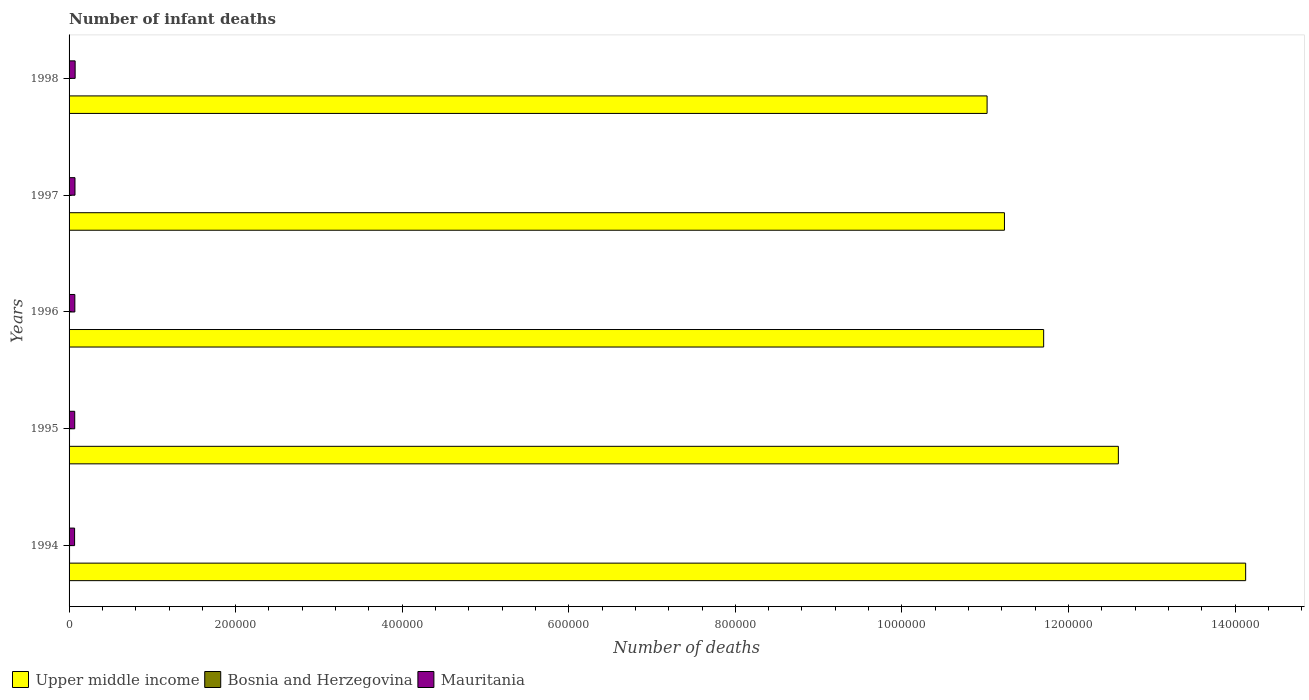How many groups of bars are there?
Ensure brevity in your answer.  5. How many bars are there on the 5th tick from the bottom?
Provide a short and direct response. 3. What is the label of the 2nd group of bars from the top?
Ensure brevity in your answer.  1997. In how many cases, is the number of bars for a given year not equal to the number of legend labels?
Your answer should be very brief. 0. What is the number of infant deaths in Mauritania in 1998?
Ensure brevity in your answer.  7281. Across all years, what is the maximum number of infant deaths in Bosnia and Herzegovina?
Provide a short and direct response. 579. Across all years, what is the minimum number of infant deaths in Upper middle income?
Provide a short and direct response. 1.10e+06. In which year was the number of infant deaths in Mauritania minimum?
Ensure brevity in your answer.  1994. What is the total number of infant deaths in Bosnia and Herzegovina in the graph?
Your answer should be compact. 2478. What is the difference between the number of infant deaths in Bosnia and Herzegovina in 1994 and the number of infant deaths in Mauritania in 1996?
Provide a short and direct response. -6357. What is the average number of infant deaths in Mauritania per year?
Give a very brief answer. 6945.4. In the year 1998, what is the difference between the number of infant deaths in Mauritania and number of infant deaths in Bosnia and Herzegovina?
Your response must be concise. 6840. What is the ratio of the number of infant deaths in Mauritania in 1996 to that in 1998?
Offer a very short reply. 0.95. Is the difference between the number of infant deaths in Mauritania in 1995 and 1997 greater than the difference between the number of infant deaths in Bosnia and Herzegovina in 1995 and 1997?
Give a very brief answer. No. What is the difference between the highest and the second highest number of infant deaths in Mauritania?
Offer a terse response. 178. What is the difference between the highest and the lowest number of infant deaths in Mauritania?
Your answer should be very brief. 656. In how many years, is the number of infant deaths in Bosnia and Herzegovina greater than the average number of infant deaths in Bosnia and Herzegovina taken over all years?
Provide a short and direct response. 2. What does the 3rd bar from the top in 1995 represents?
Give a very brief answer. Upper middle income. What does the 3rd bar from the bottom in 1995 represents?
Your response must be concise. Mauritania. What is the difference between two consecutive major ticks on the X-axis?
Your answer should be very brief. 2.00e+05. Are the values on the major ticks of X-axis written in scientific E-notation?
Offer a very short reply. No. Does the graph contain any zero values?
Your response must be concise. No. Where does the legend appear in the graph?
Give a very brief answer. Bottom left. What is the title of the graph?
Offer a terse response. Number of infant deaths. Does "Burundi" appear as one of the legend labels in the graph?
Ensure brevity in your answer.  No. What is the label or title of the X-axis?
Provide a short and direct response. Number of deaths. What is the label or title of the Y-axis?
Make the answer very short. Years. What is the Number of deaths of Upper middle income in 1994?
Your answer should be compact. 1.41e+06. What is the Number of deaths of Bosnia and Herzegovina in 1994?
Ensure brevity in your answer.  579. What is the Number of deaths in Mauritania in 1994?
Your answer should be compact. 6625. What is the Number of deaths in Upper middle income in 1995?
Provide a succinct answer. 1.26e+06. What is the Number of deaths in Bosnia and Herzegovina in 1995?
Provide a succinct answer. 533. What is the Number of deaths of Mauritania in 1995?
Offer a terse response. 6782. What is the Number of deaths of Upper middle income in 1996?
Keep it short and to the point. 1.17e+06. What is the Number of deaths in Bosnia and Herzegovina in 1996?
Keep it short and to the point. 473. What is the Number of deaths in Mauritania in 1996?
Provide a succinct answer. 6936. What is the Number of deaths of Upper middle income in 1997?
Give a very brief answer. 1.12e+06. What is the Number of deaths in Bosnia and Herzegovina in 1997?
Ensure brevity in your answer.  452. What is the Number of deaths of Mauritania in 1997?
Provide a succinct answer. 7103. What is the Number of deaths in Upper middle income in 1998?
Make the answer very short. 1.10e+06. What is the Number of deaths of Bosnia and Herzegovina in 1998?
Your answer should be compact. 441. What is the Number of deaths in Mauritania in 1998?
Your response must be concise. 7281. Across all years, what is the maximum Number of deaths in Upper middle income?
Ensure brevity in your answer.  1.41e+06. Across all years, what is the maximum Number of deaths in Bosnia and Herzegovina?
Your response must be concise. 579. Across all years, what is the maximum Number of deaths of Mauritania?
Give a very brief answer. 7281. Across all years, what is the minimum Number of deaths in Upper middle income?
Offer a terse response. 1.10e+06. Across all years, what is the minimum Number of deaths in Bosnia and Herzegovina?
Your answer should be very brief. 441. Across all years, what is the minimum Number of deaths in Mauritania?
Offer a very short reply. 6625. What is the total Number of deaths in Upper middle income in the graph?
Ensure brevity in your answer.  6.07e+06. What is the total Number of deaths of Bosnia and Herzegovina in the graph?
Offer a very short reply. 2478. What is the total Number of deaths of Mauritania in the graph?
Offer a terse response. 3.47e+04. What is the difference between the Number of deaths of Upper middle income in 1994 and that in 1995?
Offer a terse response. 1.53e+05. What is the difference between the Number of deaths in Bosnia and Herzegovina in 1994 and that in 1995?
Give a very brief answer. 46. What is the difference between the Number of deaths of Mauritania in 1994 and that in 1995?
Provide a short and direct response. -157. What is the difference between the Number of deaths of Upper middle income in 1994 and that in 1996?
Keep it short and to the point. 2.43e+05. What is the difference between the Number of deaths in Bosnia and Herzegovina in 1994 and that in 1996?
Your answer should be compact. 106. What is the difference between the Number of deaths of Mauritania in 1994 and that in 1996?
Give a very brief answer. -311. What is the difference between the Number of deaths in Upper middle income in 1994 and that in 1997?
Provide a short and direct response. 2.90e+05. What is the difference between the Number of deaths of Bosnia and Herzegovina in 1994 and that in 1997?
Offer a very short reply. 127. What is the difference between the Number of deaths in Mauritania in 1994 and that in 1997?
Ensure brevity in your answer.  -478. What is the difference between the Number of deaths of Upper middle income in 1994 and that in 1998?
Your answer should be very brief. 3.10e+05. What is the difference between the Number of deaths of Bosnia and Herzegovina in 1994 and that in 1998?
Give a very brief answer. 138. What is the difference between the Number of deaths of Mauritania in 1994 and that in 1998?
Your response must be concise. -656. What is the difference between the Number of deaths in Upper middle income in 1995 and that in 1996?
Give a very brief answer. 8.97e+04. What is the difference between the Number of deaths of Bosnia and Herzegovina in 1995 and that in 1996?
Your response must be concise. 60. What is the difference between the Number of deaths in Mauritania in 1995 and that in 1996?
Offer a terse response. -154. What is the difference between the Number of deaths in Upper middle income in 1995 and that in 1997?
Your answer should be very brief. 1.37e+05. What is the difference between the Number of deaths in Bosnia and Herzegovina in 1995 and that in 1997?
Your response must be concise. 81. What is the difference between the Number of deaths in Mauritania in 1995 and that in 1997?
Provide a short and direct response. -321. What is the difference between the Number of deaths in Upper middle income in 1995 and that in 1998?
Provide a succinct answer. 1.58e+05. What is the difference between the Number of deaths of Bosnia and Herzegovina in 1995 and that in 1998?
Offer a very short reply. 92. What is the difference between the Number of deaths of Mauritania in 1995 and that in 1998?
Offer a very short reply. -499. What is the difference between the Number of deaths of Upper middle income in 1996 and that in 1997?
Provide a succinct answer. 4.71e+04. What is the difference between the Number of deaths in Bosnia and Herzegovina in 1996 and that in 1997?
Give a very brief answer. 21. What is the difference between the Number of deaths of Mauritania in 1996 and that in 1997?
Ensure brevity in your answer.  -167. What is the difference between the Number of deaths of Upper middle income in 1996 and that in 1998?
Provide a short and direct response. 6.79e+04. What is the difference between the Number of deaths in Bosnia and Herzegovina in 1996 and that in 1998?
Your answer should be very brief. 32. What is the difference between the Number of deaths in Mauritania in 1996 and that in 1998?
Ensure brevity in your answer.  -345. What is the difference between the Number of deaths of Upper middle income in 1997 and that in 1998?
Keep it short and to the point. 2.08e+04. What is the difference between the Number of deaths of Mauritania in 1997 and that in 1998?
Provide a succinct answer. -178. What is the difference between the Number of deaths of Upper middle income in 1994 and the Number of deaths of Bosnia and Herzegovina in 1995?
Your answer should be very brief. 1.41e+06. What is the difference between the Number of deaths in Upper middle income in 1994 and the Number of deaths in Mauritania in 1995?
Keep it short and to the point. 1.41e+06. What is the difference between the Number of deaths of Bosnia and Herzegovina in 1994 and the Number of deaths of Mauritania in 1995?
Your response must be concise. -6203. What is the difference between the Number of deaths of Upper middle income in 1994 and the Number of deaths of Bosnia and Herzegovina in 1996?
Offer a terse response. 1.41e+06. What is the difference between the Number of deaths in Upper middle income in 1994 and the Number of deaths in Mauritania in 1996?
Provide a succinct answer. 1.41e+06. What is the difference between the Number of deaths in Bosnia and Herzegovina in 1994 and the Number of deaths in Mauritania in 1996?
Provide a short and direct response. -6357. What is the difference between the Number of deaths of Upper middle income in 1994 and the Number of deaths of Bosnia and Herzegovina in 1997?
Your answer should be compact. 1.41e+06. What is the difference between the Number of deaths in Upper middle income in 1994 and the Number of deaths in Mauritania in 1997?
Offer a terse response. 1.41e+06. What is the difference between the Number of deaths in Bosnia and Herzegovina in 1994 and the Number of deaths in Mauritania in 1997?
Make the answer very short. -6524. What is the difference between the Number of deaths in Upper middle income in 1994 and the Number of deaths in Bosnia and Herzegovina in 1998?
Your answer should be very brief. 1.41e+06. What is the difference between the Number of deaths of Upper middle income in 1994 and the Number of deaths of Mauritania in 1998?
Provide a succinct answer. 1.41e+06. What is the difference between the Number of deaths in Bosnia and Herzegovina in 1994 and the Number of deaths in Mauritania in 1998?
Your response must be concise. -6702. What is the difference between the Number of deaths in Upper middle income in 1995 and the Number of deaths in Bosnia and Herzegovina in 1996?
Offer a terse response. 1.26e+06. What is the difference between the Number of deaths in Upper middle income in 1995 and the Number of deaths in Mauritania in 1996?
Ensure brevity in your answer.  1.25e+06. What is the difference between the Number of deaths of Bosnia and Herzegovina in 1995 and the Number of deaths of Mauritania in 1996?
Provide a short and direct response. -6403. What is the difference between the Number of deaths of Upper middle income in 1995 and the Number of deaths of Bosnia and Herzegovina in 1997?
Ensure brevity in your answer.  1.26e+06. What is the difference between the Number of deaths in Upper middle income in 1995 and the Number of deaths in Mauritania in 1997?
Keep it short and to the point. 1.25e+06. What is the difference between the Number of deaths in Bosnia and Herzegovina in 1995 and the Number of deaths in Mauritania in 1997?
Keep it short and to the point. -6570. What is the difference between the Number of deaths of Upper middle income in 1995 and the Number of deaths of Bosnia and Herzegovina in 1998?
Give a very brief answer. 1.26e+06. What is the difference between the Number of deaths in Upper middle income in 1995 and the Number of deaths in Mauritania in 1998?
Your answer should be very brief. 1.25e+06. What is the difference between the Number of deaths of Bosnia and Herzegovina in 1995 and the Number of deaths of Mauritania in 1998?
Offer a terse response. -6748. What is the difference between the Number of deaths in Upper middle income in 1996 and the Number of deaths in Bosnia and Herzegovina in 1997?
Your answer should be compact. 1.17e+06. What is the difference between the Number of deaths of Upper middle income in 1996 and the Number of deaths of Mauritania in 1997?
Provide a short and direct response. 1.16e+06. What is the difference between the Number of deaths in Bosnia and Herzegovina in 1996 and the Number of deaths in Mauritania in 1997?
Offer a very short reply. -6630. What is the difference between the Number of deaths in Upper middle income in 1996 and the Number of deaths in Bosnia and Herzegovina in 1998?
Offer a very short reply. 1.17e+06. What is the difference between the Number of deaths in Upper middle income in 1996 and the Number of deaths in Mauritania in 1998?
Provide a short and direct response. 1.16e+06. What is the difference between the Number of deaths in Bosnia and Herzegovina in 1996 and the Number of deaths in Mauritania in 1998?
Provide a succinct answer. -6808. What is the difference between the Number of deaths of Upper middle income in 1997 and the Number of deaths of Bosnia and Herzegovina in 1998?
Give a very brief answer. 1.12e+06. What is the difference between the Number of deaths of Upper middle income in 1997 and the Number of deaths of Mauritania in 1998?
Your response must be concise. 1.12e+06. What is the difference between the Number of deaths in Bosnia and Herzegovina in 1997 and the Number of deaths in Mauritania in 1998?
Keep it short and to the point. -6829. What is the average Number of deaths of Upper middle income per year?
Offer a very short reply. 1.21e+06. What is the average Number of deaths of Bosnia and Herzegovina per year?
Offer a terse response. 495.6. What is the average Number of deaths in Mauritania per year?
Make the answer very short. 6945.4. In the year 1994, what is the difference between the Number of deaths in Upper middle income and Number of deaths in Bosnia and Herzegovina?
Give a very brief answer. 1.41e+06. In the year 1994, what is the difference between the Number of deaths of Upper middle income and Number of deaths of Mauritania?
Ensure brevity in your answer.  1.41e+06. In the year 1994, what is the difference between the Number of deaths of Bosnia and Herzegovina and Number of deaths of Mauritania?
Keep it short and to the point. -6046. In the year 1995, what is the difference between the Number of deaths of Upper middle income and Number of deaths of Bosnia and Herzegovina?
Offer a very short reply. 1.26e+06. In the year 1995, what is the difference between the Number of deaths in Upper middle income and Number of deaths in Mauritania?
Offer a terse response. 1.25e+06. In the year 1995, what is the difference between the Number of deaths in Bosnia and Herzegovina and Number of deaths in Mauritania?
Ensure brevity in your answer.  -6249. In the year 1996, what is the difference between the Number of deaths of Upper middle income and Number of deaths of Bosnia and Herzegovina?
Your response must be concise. 1.17e+06. In the year 1996, what is the difference between the Number of deaths in Upper middle income and Number of deaths in Mauritania?
Offer a very short reply. 1.16e+06. In the year 1996, what is the difference between the Number of deaths of Bosnia and Herzegovina and Number of deaths of Mauritania?
Your answer should be very brief. -6463. In the year 1997, what is the difference between the Number of deaths of Upper middle income and Number of deaths of Bosnia and Herzegovina?
Your response must be concise. 1.12e+06. In the year 1997, what is the difference between the Number of deaths of Upper middle income and Number of deaths of Mauritania?
Provide a succinct answer. 1.12e+06. In the year 1997, what is the difference between the Number of deaths in Bosnia and Herzegovina and Number of deaths in Mauritania?
Provide a succinct answer. -6651. In the year 1998, what is the difference between the Number of deaths in Upper middle income and Number of deaths in Bosnia and Herzegovina?
Provide a succinct answer. 1.10e+06. In the year 1998, what is the difference between the Number of deaths of Upper middle income and Number of deaths of Mauritania?
Ensure brevity in your answer.  1.10e+06. In the year 1998, what is the difference between the Number of deaths of Bosnia and Herzegovina and Number of deaths of Mauritania?
Your answer should be very brief. -6840. What is the ratio of the Number of deaths in Upper middle income in 1994 to that in 1995?
Your answer should be compact. 1.12. What is the ratio of the Number of deaths in Bosnia and Herzegovina in 1994 to that in 1995?
Offer a terse response. 1.09. What is the ratio of the Number of deaths of Mauritania in 1994 to that in 1995?
Offer a very short reply. 0.98. What is the ratio of the Number of deaths in Upper middle income in 1994 to that in 1996?
Provide a short and direct response. 1.21. What is the ratio of the Number of deaths in Bosnia and Herzegovina in 1994 to that in 1996?
Ensure brevity in your answer.  1.22. What is the ratio of the Number of deaths of Mauritania in 1994 to that in 1996?
Your response must be concise. 0.96. What is the ratio of the Number of deaths in Upper middle income in 1994 to that in 1997?
Your answer should be very brief. 1.26. What is the ratio of the Number of deaths in Bosnia and Herzegovina in 1994 to that in 1997?
Give a very brief answer. 1.28. What is the ratio of the Number of deaths of Mauritania in 1994 to that in 1997?
Give a very brief answer. 0.93. What is the ratio of the Number of deaths in Upper middle income in 1994 to that in 1998?
Offer a very short reply. 1.28. What is the ratio of the Number of deaths of Bosnia and Herzegovina in 1994 to that in 1998?
Your response must be concise. 1.31. What is the ratio of the Number of deaths in Mauritania in 1994 to that in 1998?
Provide a succinct answer. 0.91. What is the ratio of the Number of deaths in Upper middle income in 1995 to that in 1996?
Offer a terse response. 1.08. What is the ratio of the Number of deaths of Bosnia and Herzegovina in 1995 to that in 1996?
Provide a succinct answer. 1.13. What is the ratio of the Number of deaths of Mauritania in 1995 to that in 1996?
Provide a succinct answer. 0.98. What is the ratio of the Number of deaths in Upper middle income in 1995 to that in 1997?
Provide a short and direct response. 1.12. What is the ratio of the Number of deaths in Bosnia and Herzegovina in 1995 to that in 1997?
Give a very brief answer. 1.18. What is the ratio of the Number of deaths in Mauritania in 1995 to that in 1997?
Your answer should be very brief. 0.95. What is the ratio of the Number of deaths in Upper middle income in 1995 to that in 1998?
Make the answer very short. 1.14. What is the ratio of the Number of deaths of Bosnia and Herzegovina in 1995 to that in 1998?
Offer a very short reply. 1.21. What is the ratio of the Number of deaths in Mauritania in 1995 to that in 1998?
Your answer should be very brief. 0.93. What is the ratio of the Number of deaths in Upper middle income in 1996 to that in 1997?
Make the answer very short. 1.04. What is the ratio of the Number of deaths in Bosnia and Herzegovina in 1996 to that in 1997?
Offer a terse response. 1.05. What is the ratio of the Number of deaths in Mauritania in 1996 to that in 1997?
Provide a succinct answer. 0.98. What is the ratio of the Number of deaths in Upper middle income in 1996 to that in 1998?
Make the answer very short. 1.06. What is the ratio of the Number of deaths in Bosnia and Herzegovina in 1996 to that in 1998?
Provide a succinct answer. 1.07. What is the ratio of the Number of deaths in Mauritania in 1996 to that in 1998?
Keep it short and to the point. 0.95. What is the ratio of the Number of deaths in Upper middle income in 1997 to that in 1998?
Offer a very short reply. 1.02. What is the ratio of the Number of deaths in Bosnia and Herzegovina in 1997 to that in 1998?
Give a very brief answer. 1.02. What is the ratio of the Number of deaths in Mauritania in 1997 to that in 1998?
Make the answer very short. 0.98. What is the difference between the highest and the second highest Number of deaths in Upper middle income?
Offer a very short reply. 1.53e+05. What is the difference between the highest and the second highest Number of deaths of Bosnia and Herzegovina?
Make the answer very short. 46. What is the difference between the highest and the second highest Number of deaths of Mauritania?
Provide a succinct answer. 178. What is the difference between the highest and the lowest Number of deaths in Upper middle income?
Your response must be concise. 3.10e+05. What is the difference between the highest and the lowest Number of deaths in Bosnia and Herzegovina?
Your response must be concise. 138. What is the difference between the highest and the lowest Number of deaths of Mauritania?
Your response must be concise. 656. 